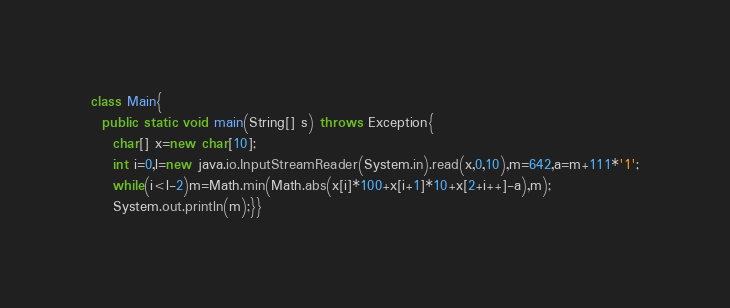Convert code to text. <code><loc_0><loc_0><loc_500><loc_500><_Java_>class Main{
  public static void main(String[] s) throws Exception{
    char[] x=new char[10];
    int i=0,l=new java.io.InputStreamReader(System.in).read(x,0,10),m=642,a=m+111*'1';
    while(i<l-2)m=Math.min(Math.abs(x[i]*100+x[i+1]*10+x[2+i++]-a),m);
    System.out.println(m);}}
</code> 